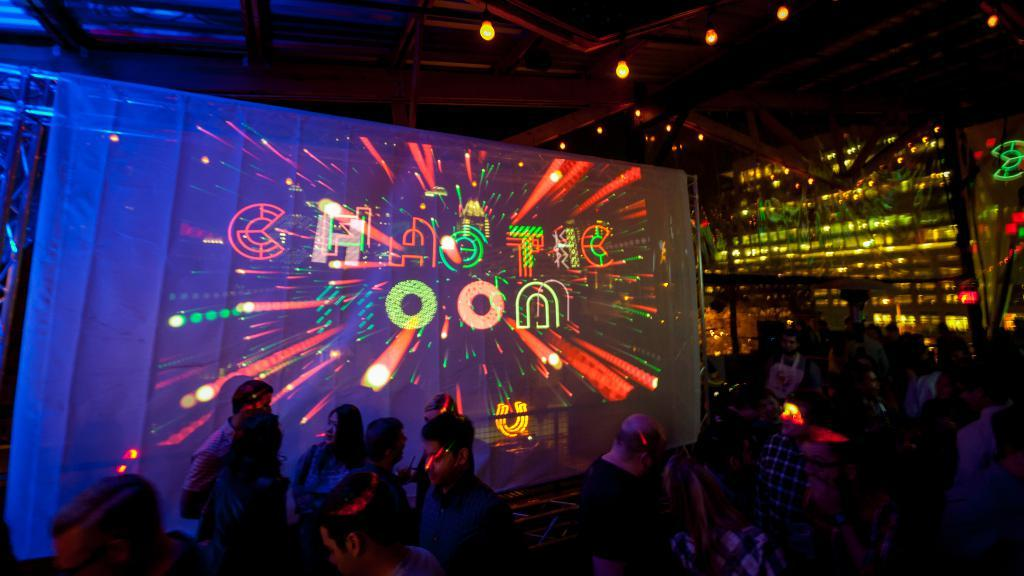<image>
Give a short and clear explanation of the subsequent image. A very large screen that reads. Chaotic Moon and flashes of colorful lights. 